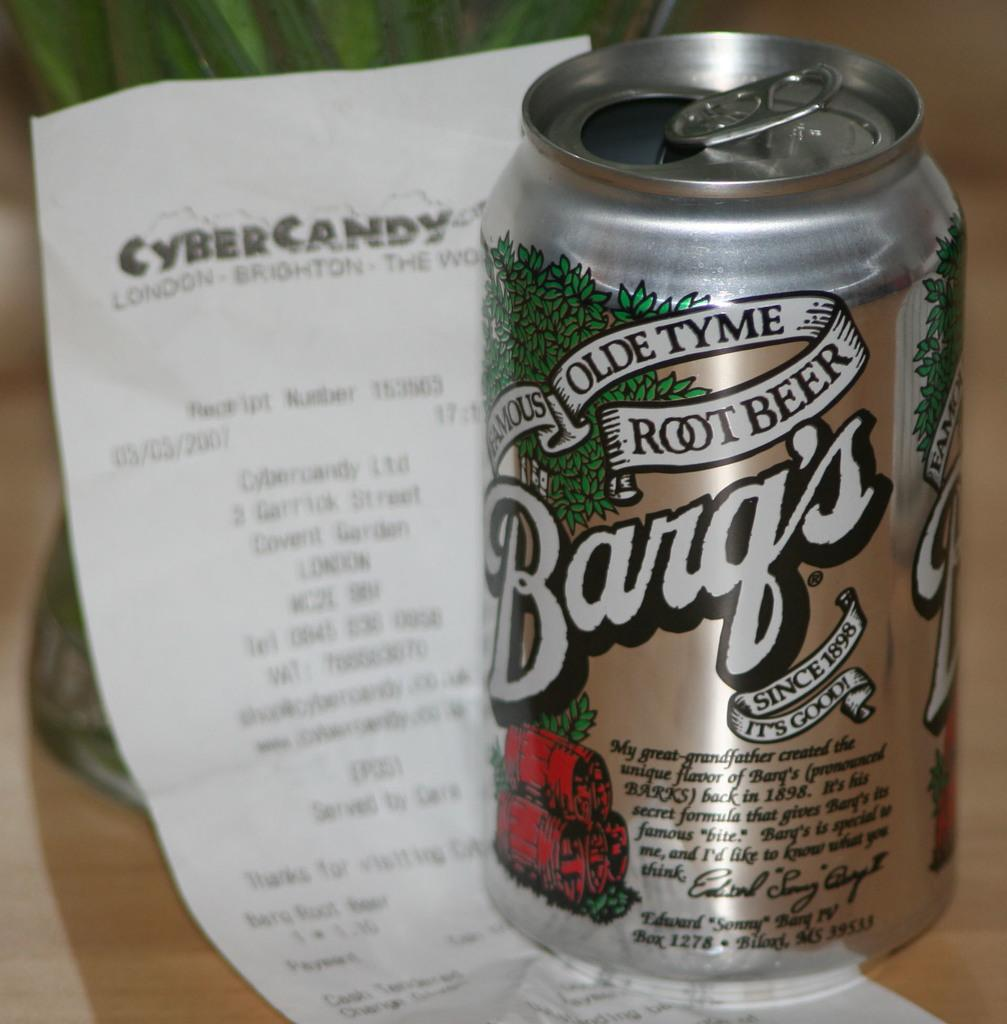<image>
Share a concise interpretation of the image provided. A can of Barq's root beer holds down a receipt from a store. 